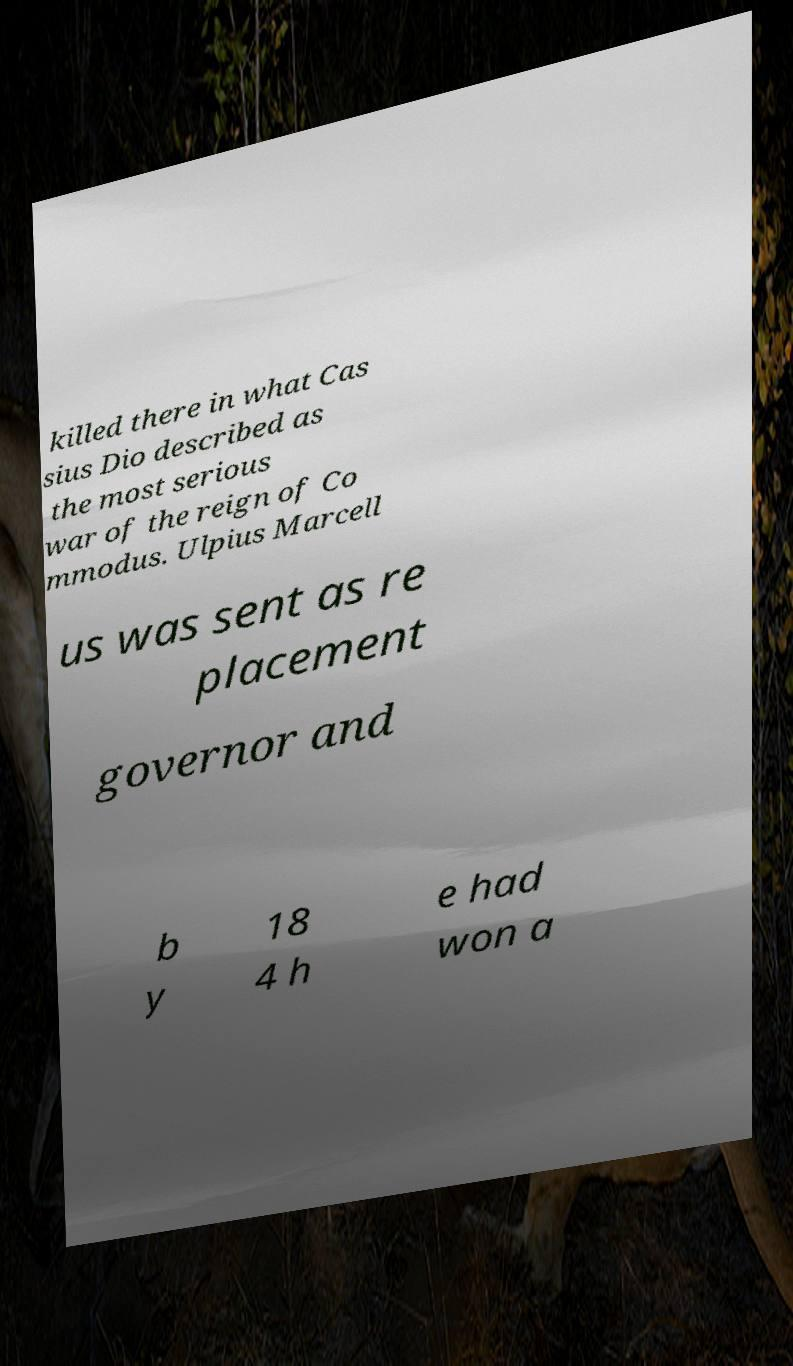I need the written content from this picture converted into text. Can you do that? killed there in what Cas sius Dio described as the most serious war of the reign of Co mmodus. Ulpius Marcell us was sent as re placement governor and b y 18 4 h e had won a 